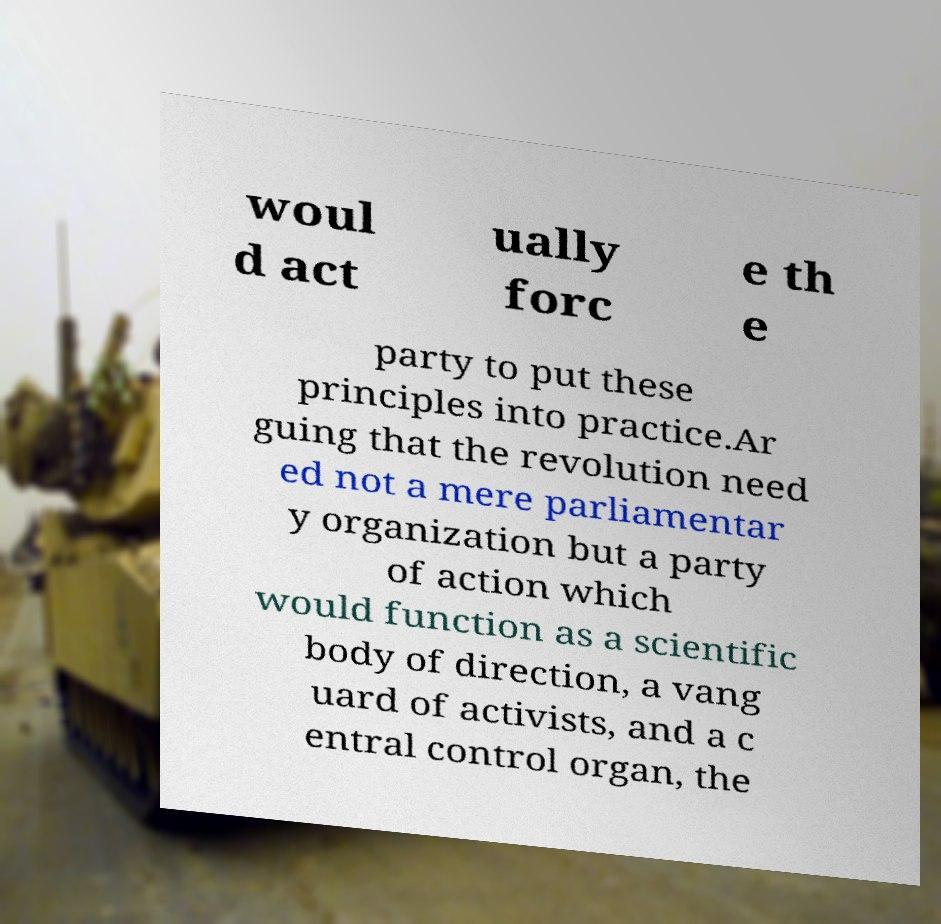Could you extract and type out the text from this image? woul d act ually forc e th e party to put these principles into practice.Ar guing that the revolution need ed not a mere parliamentar y organization but a party of action which would function as a scientific body of direction, a vang uard of activists, and a c entral control organ, the 